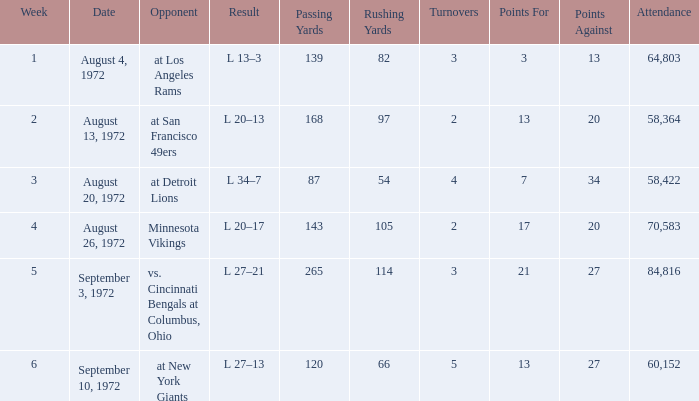What is the lowest attendance on September 3, 1972? 84816.0. 